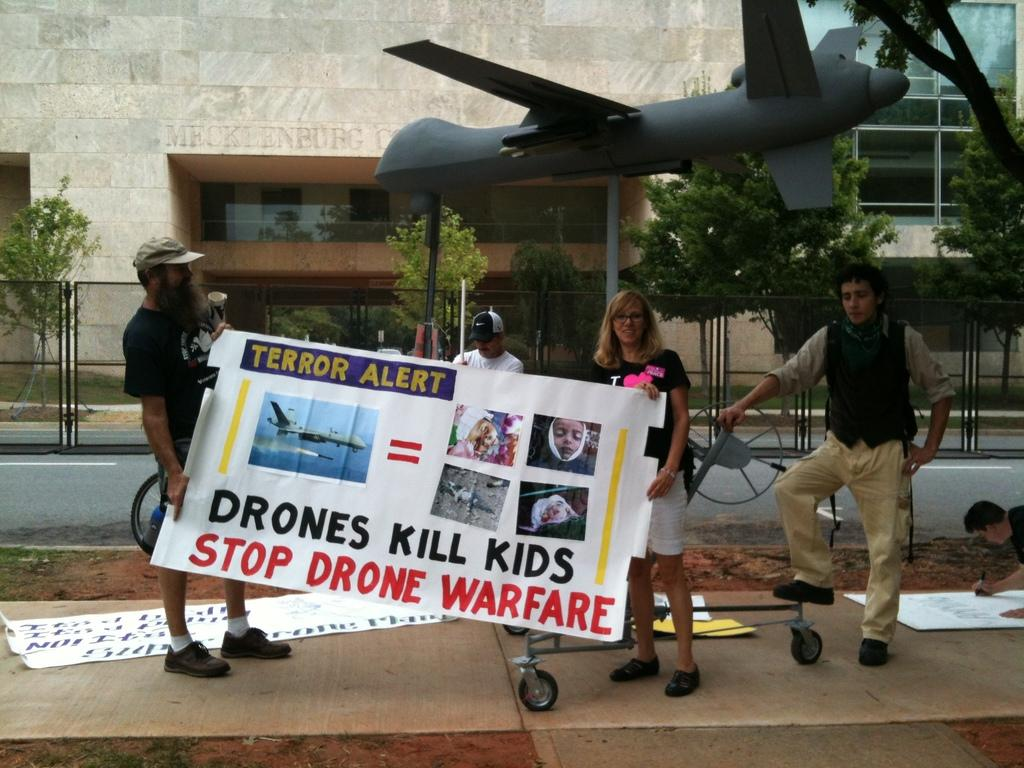How many people are in the image? There is a group of people in the image. What are two people in the group doing? Two people are standing and holding a banner. What can be found on the path in the image? There are papers on the path. What is the demo airplane used for in the image? The demo airplane is a model or representation of an airplane, likely for display purposes. What type of structures can be seen in the image? There are buildings visible in the image. What type of vegetation is present in the image? Trees are present in the image. Can you see a pail being used by someone at the seashore in the image? There is no seashore or pail present in the image. 